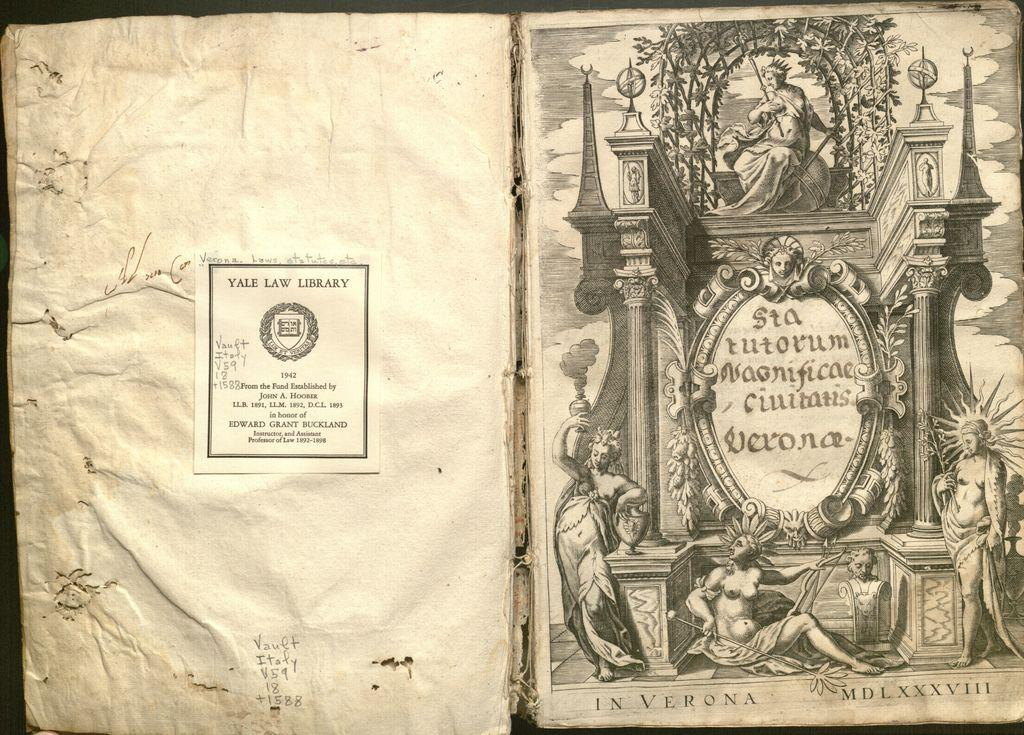<image>
Render a clear and concise summary of the photo. Ancient book which is owned by the Yale Law Library. 